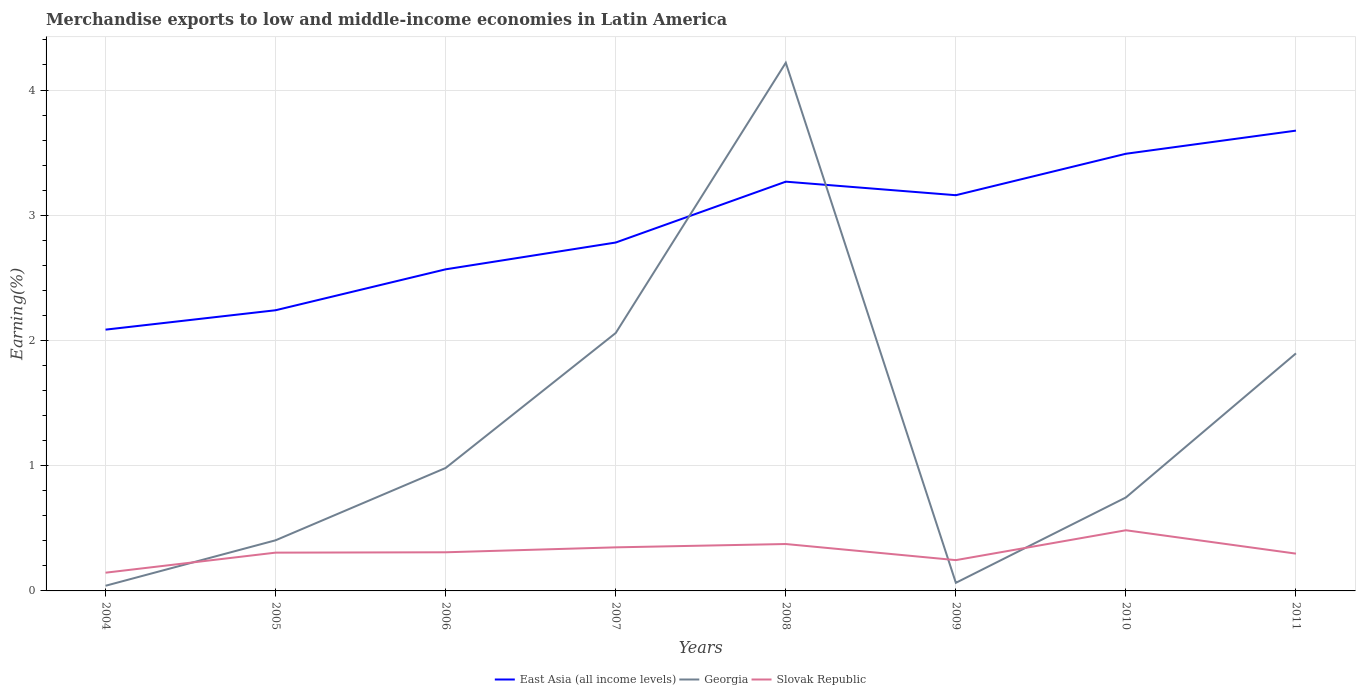Does the line corresponding to Georgia intersect with the line corresponding to East Asia (all income levels)?
Keep it short and to the point. Yes. Is the number of lines equal to the number of legend labels?
Your answer should be compact. Yes. Across all years, what is the maximum percentage of amount earned from merchandise exports in East Asia (all income levels)?
Your answer should be compact. 2.09. In which year was the percentage of amount earned from merchandise exports in Slovak Republic maximum?
Your answer should be compact. 2004. What is the total percentage of amount earned from merchandise exports in Georgia in the graph?
Provide a short and direct response. -1.08. What is the difference between the highest and the second highest percentage of amount earned from merchandise exports in East Asia (all income levels)?
Your response must be concise. 1.59. What is the difference between the highest and the lowest percentage of amount earned from merchandise exports in Georgia?
Provide a succinct answer. 3. How many years are there in the graph?
Your answer should be very brief. 8. What is the difference between two consecutive major ticks on the Y-axis?
Provide a short and direct response. 1. Are the values on the major ticks of Y-axis written in scientific E-notation?
Give a very brief answer. No. Does the graph contain grids?
Offer a terse response. Yes. What is the title of the graph?
Provide a succinct answer. Merchandise exports to low and middle-income economies in Latin America. Does "Fragile and conflict affected situations" appear as one of the legend labels in the graph?
Provide a short and direct response. No. What is the label or title of the X-axis?
Give a very brief answer. Years. What is the label or title of the Y-axis?
Provide a succinct answer. Earning(%). What is the Earning(%) in East Asia (all income levels) in 2004?
Offer a terse response. 2.09. What is the Earning(%) in Georgia in 2004?
Ensure brevity in your answer.  0.04. What is the Earning(%) of Slovak Republic in 2004?
Your response must be concise. 0.15. What is the Earning(%) in East Asia (all income levels) in 2005?
Ensure brevity in your answer.  2.24. What is the Earning(%) of Georgia in 2005?
Make the answer very short. 0.4. What is the Earning(%) of Slovak Republic in 2005?
Keep it short and to the point. 0.31. What is the Earning(%) of East Asia (all income levels) in 2006?
Provide a short and direct response. 2.57. What is the Earning(%) of Georgia in 2006?
Ensure brevity in your answer.  0.98. What is the Earning(%) in Slovak Republic in 2006?
Keep it short and to the point. 0.31. What is the Earning(%) in East Asia (all income levels) in 2007?
Give a very brief answer. 2.78. What is the Earning(%) in Georgia in 2007?
Give a very brief answer. 2.06. What is the Earning(%) of Slovak Republic in 2007?
Offer a very short reply. 0.35. What is the Earning(%) of East Asia (all income levels) in 2008?
Your answer should be very brief. 3.27. What is the Earning(%) in Georgia in 2008?
Give a very brief answer. 4.22. What is the Earning(%) of Slovak Republic in 2008?
Your response must be concise. 0.37. What is the Earning(%) of East Asia (all income levels) in 2009?
Ensure brevity in your answer.  3.16. What is the Earning(%) in Georgia in 2009?
Provide a succinct answer. 0.06. What is the Earning(%) of Slovak Republic in 2009?
Ensure brevity in your answer.  0.25. What is the Earning(%) of East Asia (all income levels) in 2010?
Offer a terse response. 3.49. What is the Earning(%) in Georgia in 2010?
Offer a very short reply. 0.75. What is the Earning(%) of Slovak Republic in 2010?
Ensure brevity in your answer.  0.48. What is the Earning(%) in East Asia (all income levels) in 2011?
Your answer should be compact. 3.68. What is the Earning(%) in Georgia in 2011?
Your answer should be compact. 1.9. What is the Earning(%) of Slovak Republic in 2011?
Provide a short and direct response. 0.3. Across all years, what is the maximum Earning(%) in East Asia (all income levels)?
Provide a succinct answer. 3.68. Across all years, what is the maximum Earning(%) of Georgia?
Your answer should be very brief. 4.22. Across all years, what is the maximum Earning(%) of Slovak Republic?
Give a very brief answer. 0.48. Across all years, what is the minimum Earning(%) of East Asia (all income levels)?
Offer a terse response. 2.09. Across all years, what is the minimum Earning(%) of Georgia?
Make the answer very short. 0.04. Across all years, what is the minimum Earning(%) in Slovak Republic?
Your answer should be very brief. 0.15. What is the total Earning(%) in East Asia (all income levels) in the graph?
Offer a terse response. 23.27. What is the total Earning(%) of Georgia in the graph?
Keep it short and to the point. 10.41. What is the total Earning(%) of Slovak Republic in the graph?
Your answer should be very brief. 2.51. What is the difference between the Earning(%) of East Asia (all income levels) in 2004 and that in 2005?
Offer a terse response. -0.15. What is the difference between the Earning(%) of Georgia in 2004 and that in 2005?
Provide a short and direct response. -0.36. What is the difference between the Earning(%) in Slovak Republic in 2004 and that in 2005?
Make the answer very short. -0.16. What is the difference between the Earning(%) of East Asia (all income levels) in 2004 and that in 2006?
Keep it short and to the point. -0.48. What is the difference between the Earning(%) in Georgia in 2004 and that in 2006?
Give a very brief answer. -0.94. What is the difference between the Earning(%) in Slovak Republic in 2004 and that in 2006?
Provide a succinct answer. -0.16. What is the difference between the Earning(%) of East Asia (all income levels) in 2004 and that in 2007?
Your response must be concise. -0.7. What is the difference between the Earning(%) of Georgia in 2004 and that in 2007?
Offer a very short reply. -2.02. What is the difference between the Earning(%) of Slovak Republic in 2004 and that in 2007?
Provide a short and direct response. -0.2. What is the difference between the Earning(%) of East Asia (all income levels) in 2004 and that in 2008?
Your response must be concise. -1.18. What is the difference between the Earning(%) in Georgia in 2004 and that in 2008?
Make the answer very short. -4.18. What is the difference between the Earning(%) in Slovak Republic in 2004 and that in 2008?
Your response must be concise. -0.23. What is the difference between the Earning(%) in East Asia (all income levels) in 2004 and that in 2009?
Your response must be concise. -1.07. What is the difference between the Earning(%) of Georgia in 2004 and that in 2009?
Provide a short and direct response. -0.02. What is the difference between the Earning(%) in Slovak Republic in 2004 and that in 2009?
Offer a terse response. -0.1. What is the difference between the Earning(%) of East Asia (all income levels) in 2004 and that in 2010?
Offer a terse response. -1.4. What is the difference between the Earning(%) in Georgia in 2004 and that in 2010?
Ensure brevity in your answer.  -0.71. What is the difference between the Earning(%) in Slovak Republic in 2004 and that in 2010?
Your answer should be very brief. -0.34. What is the difference between the Earning(%) in East Asia (all income levels) in 2004 and that in 2011?
Your answer should be very brief. -1.59. What is the difference between the Earning(%) in Georgia in 2004 and that in 2011?
Make the answer very short. -1.86. What is the difference between the Earning(%) in Slovak Republic in 2004 and that in 2011?
Provide a succinct answer. -0.15. What is the difference between the Earning(%) in East Asia (all income levels) in 2005 and that in 2006?
Ensure brevity in your answer.  -0.33. What is the difference between the Earning(%) of Georgia in 2005 and that in 2006?
Ensure brevity in your answer.  -0.58. What is the difference between the Earning(%) in Slovak Republic in 2005 and that in 2006?
Ensure brevity in your answer.  -0. What is the difference between the Earning(%) of East Asia (all income levels) in 2005 and that in 2007?
Provide a succinct answer. -0.54. What is the difference between the Earning(%) of Georgia in 2005 and that in 2007?
Provide a succinct answer. -1.66. What is the difference between the Earning(%) in Slovak Republic in 2005 and that in 2007?
Your answer should be very brief. -0.04. What is the difference between the Earning(%) in East Asia (all income levels) in 2005 and that in 2008?
Ensure brevity in your answer.  -1.03. What is the difference between the Earning(%) in Georgia in 2005 and that in 2008?
Ensure brevity in your answer.  -3.81. What is the difference between the Earning(%) in Slovak Republic in 2005 and that in 2008?
Ensure brevity in your answer.  -0.07. What is the difference between the Earning(%) of East Asia (all income levels) in 2005 and that in 2009?
Your answer should be very brief. -0.92. What is the difference between the Earning(%) of Georgia in 2005 and that in 2009?
Your response must be concise. 0.34. What is the difference between the Earning(%) in Slovak Republic in 2005 and that in 2009?
Your answer should be compact. 0.06. What is the difference between the Earning(%) in East Asia (all income levels) in 2005 and that in 2010?
Ensure brevity in your answer.  -1.25. What is the difference between the Earning(%) of Georgia in 2005 and that in 2010?
Offer a very short reply. -0.34. What is the difference between the Earning(%) of Slovak Republic in 2005 and that in 2010?
Your answer should be very brief. -0.18. What is the difference between the Earning(%) in East Asia (all income levels) in 2005 and that in 2011?
Keep it short and to the point. -1.43. What is the difference between the Earning(%) in Georgia in 2005 and that in 2011?
Your answer should be very brief. -1.49. What is the difference between the Earning(%) of Slovak Republic in 2005 and that in 2011?
Provide a short and direct response. 0.01. What is the difference between the Earning(%) of East Asia (all income levels) in 2006 and that in 2007?
Your answer should be compact. -0.21. What is the difference between the Earning(%) of Georgia in 2006 and that in 2007?
Offer a terse response. -1.08. What is the difference between the Earning(%) of Slovak Republic in 2006 and that in 2007?
Your response must be concise. -0.04. What is the difference between the Earning(%) in Georgia in 2006 and that in 2008?
Offer a very short reply. -3.24. What is the difference between the Earning(%) of Slovak Republic in 2006 and that in 2008?
Provide a short and direct response. -0.07. What is the difference between the Earning(%) in East Asia (all income levels) in 2006 and that in 2009?
Keep it short and to the point. -0.59. What is the difference between the Earning(%) in Georgia in 2006 and that in 2009?
Give a very brief answer. 0.92. What is the difference between the Earning(%) in Slovak Republic in 2006 and that in 2009?
Give a very brief answer. 0.06. What is the difference between the Earning(%) in East Asia (all income levels) in 2006 and that in 2010?
Your response must be concise. -0.92. What is the difference between the Earning(%) in Georgia in 2006 and that in 2010?
Ensure brevity in your answer.  0.24. What is the difference between the Earning(%) in Slovak Republic in 2006 and that in 2010?
Make the answer very short. -0.18. What is the difference between the Earning(%) in East Asia (all income levels) in 2006 and that in 2011?
Make the answer very short. -1.11. What is the difference between the Earning(%) of Georgia in 2006 and that in 2011?
Ensure brevity in your answer.  -0.92. What is the difference between the Earning(%) in Slovak Republic in 2006 and that in 2011?
Provide a short and direct response. 0.01. What is the difference between the Earning(%) of East Asia (all income levels) in 2007 and that in 2008?
Your response must be concise. -0.49. What is the difference between the Earning(%) of Georgia in 2007 and that in 2008?
Your answer should be very brief. -2.16. What is the difference between the Earning(%) in Slovak Republic in 2007 and that in 2008?
Keep it short and to the point. -0.03. What is the difference between the Earning(%) of East Asia (all income levels) in 2007 and that in 2009?
Provide a short and direct response. -0.38. What is the difference between the Earning(%) in Georgia in 2007 and that in 2009?
Provide a short and direct response. 2. What is the difference between the Earning(%) of Slovak Republic in 2007 and that in 2009?
Offer a very short reply. 0.1. What is the difference between the Earning(%) of East Asia (all income levels) in 2007 and that in 2010?
Provide a short and direct response. -0.71. What is the difference between the Earning(%) in Georgia in 2007 and that in 2010?
Offer a very short reply. 1.31. What is the difference between the Earning(%) in Slovak Republic in 2007 and that in 2010?
Your answer should be very brief. -0.14. What is the difference between the Earning(%) in East Asia (all income levels) in 2007 and that in 2011?
Provide a succinct answer. -0.89. What is the difference between the Earning(%) in Georgia in 2007 and that in 2011?
Your answer should be very brief. 0.16. What is the difference between the Earning(%) in Slovak Republic in 2007 and that in 2011?
Offer a terse response. 0.05. What is the difference between the Earning(%) of East Asia (all income levels) in 2008 and that in 2009?
Your response must be concise. 0.11. What is the difference between the Earning(%) in Georgia in 2008 and that in 2009?
Ensure brevity in your answer.  4.15. What is the difference between the Earning(%) of Slovak Republic in 2008 and that in 2009?
Keep it short and to the point. 0.13. What is the difference between the Earning(%) in East Asia (all income levels) in 2008 and that in 2010?
Your answer should be very brief. -0.22. What is the difference between the Earning(%) in Georgia in 2008 and that in 2010?
Provide a succinct answer. 3.47. What is the difference between the Earning(%) of Slovak Republic in 2008 and that in 2010?
Your answer should be very brief. -0.11. What is the difference between the Earning(%) of East Asia (all income levels) in 2008 and that in 2011?
Make the answer very short. -0.41. What is the difference between the Earning(%) of Georgia in 2008 and that in 2011?
Your answer should be very brief. 2.32. What is the difference between the Earning(%) of Slovak Republic in 2008 and that in 2011?
Provide a short and direct response. 0.08. What is the difference between the Earning(%) in East Asia (all income levels) in 2009 and that in 2010?
Offer a terse response. -0.33. What is the difference between the Earning(%) of Georgia in 2009 and that in 2010?
Give a very brief answer. -0.68. What is the difference between the Earning(%) of Slovak Republic in 2009 and that in 2010?
Your response must be concise. -0.24. What is the difference between the Earning(%) of East Asia (all income levels) in 2009 and that in 2011?
Offer a terse response. -0.52. What is the difference between the Earning(%) in Georgia in 2009 and that in 2011?
Offer a terse response. -1.83. What is the difference between the Earning(%) in Slovak Republic in 2009 and that in 2011?
Give a very brief answer. -0.05. What is the difference between the Earning(%) in East Asia (all income levels) in 2010 and that in 2011?
Provide a succinct answer. -0.18. What is the difference between the Earning(%) in Georgia in 2010 and that in 2011?
Provide a succinct answer. -1.15. What is the difference between the Earning(%) in Slovak Republic in 2010 and that in 2011?
Your answer should be compact. 0.19. What is the difference between the Earning(%) of East Asia (all income levels) in 2004 and the Earning(%) of Georgia in 2005?
Give a very brief answer. 1.68. What is the difference between the Earning(%) in East Asia (all income levels) in 2004 and the Earning(%) in Slovak Republic in 2005?
Give a very brief answer. 1.78. What is the difference between the Earning(%) in Georgia in 2004 and the Earning(%) in Slovak Republic in 2005?
Your answer should be compact. -0.26. What is the difference between the Earning(%) of East Asia (all income levels) in 2004 and the Earning(%) of Georgia in 2006?
Offer a terse response. 1.1. What is the difference between the Earning(%) of East Asia (all income levels) in 2004 and the Earning(%) of Slovak Republic in 2006?
Ensure brevity in your answer.  1.78. What is the difference between the Earning(%) of Georgia in 2004 and the Earning(%) of Slovak Republic in 2006?
Keep it short and to the point. -0.27. What is the difference between the Earning(%) of East Asia (all income levels) in 2004 and the Earning(%) of Georgia in 2007?
Provide a succinct answer. 0.03. What is the difference between the Earning(%) of East Asia (all income levels) in 2004 and the Earning(%) of Slovak Republic in 2007?
Provide a short and direct response. 1.74. What is the difference between the Earning(%) in Georgia in 2004 and the Earning(%) in Slovak Republic in 2007?
Give a very brief answer. -0.31. What is the difference between the Earning(%) in East Asia (all income levels) in 2004 and the Earning(%) in Georgia in 2008?
Your answer should be very brief. -2.13. What is the difference between the Earning(%) in East Asia (all income levels) in 2004 and the Earning(%) in Slovak Republic in 2008?
Provide a succinct answer. 1.71. What is the difference between the Earning(%) in Georgia in 2004 and the Earning(%) in Slovak Republic in 2008?
Give a very brief answer. -0.33. What is the difference between the Earning(%) in East Asia (all income levels) in 2004 and the Earning(%) in Georgia in 2009?
Provide a succinct answer. 2.02. What is the difference between the Earning(%) in East Asia (all income levels) in 2004 and the Earning(%) in Slovak Republic in 2009?
Offer a terse response. 1.84. What is the difference between the Earning(%) in Georgia in 2004 and the Earning(%) in Slovak Republic in 2009?
Your answer should be compact. -0.2. What is the difference between the Earning(%) of East Asia (all income levels) in 2004 and the Earning(%) of Georgia in 2010?
Offer a terse response. 1.34. What is the difference between the Earning(%) in East Asia (all income levels) in 2004 and the Earning(%) in Slovak Republic in 2010?
Your response must be concise. 1.6. What is the difference between the Earning(%) in Georgia in 2004 and the Earning(%) in Slovak Republic in 2010?
Your response must be concise. -0.44. What is the difference between the Earning(%) of East Asia (all income levels) in 2004 and the Earning(%) of Georgia in 2011?
Your answer should be compact. 0.19. What is the difference between the Earning(%) of East Asia (all income levels) in 2004 and the Earning(%) of Slovak Republic in 2011?
Offer a terse response. 1.79. What is the difference between the Earning(%) in Georgia in 2004 and the Earning(%) in Slovak Republic in 2011?
Your response must be concise. -0.26. What is the difference between the Earning(%) in East Asia (all income levels) in 2005 and the Earning(%) in Georgia in 2006?
Offer a terse response. 1.26. What is the difference between the Earning(%) in East Asia (all income levels) in 2005 and the Earning(%) in Slovak Republic in 2006?
Make the answer very short. 1.93. What is the difference between the Earning(%) in Georgia in 2005 and the Earning(%) in Slovak Republic in 2006?
Your response must be concise. 0.1. What is the difference between the Earning(%) in East Asia (all income levels) in 2005 and the Earning(%) in Georgia in 2007?
Ensure brevity in your answer.  0.18. What is the difference between the Earning(%) of East Asia (all income levels) in 2005 and the Earning(%) of Slovak Republic in 2007?
Provide a short and direct response. 1.89. What is the difference between the Earning(%) of Georgia in 2005 and the Earning(%) of Slovak Republic in 2007?
Provide a succinct answer. 0.06. What is the difference between the Earning(%) in East Asia (all income levels) in 2005 and the Earning(%) in Georgia in 2008?
Your answer should be compact. -1.98. What is the difference between the Earning(%) in East Asia (all income levels) in 2005 and the Earning(%) in Slovak Republic in 2008?
Your answer should be compact. 1.87. What is the difference between the Earning(%) of Georgia in 2005 and the Earning(%) of Slovak Republic in 2008?
Your answer should be very brief. 0.03. What is the difference between the Earning(%) in East Asia (all income levels) in 2005 and the Earning(%) in Georgia in 2009?
Your response must be concise. 2.18. What is the difference between the Earning(%) of East Asia (all income levels) in 2005 and the Earning(%) of Slovak Republic in 2009?
Provide a short and direct response. 2. What is the difference between the Earning(%) in Georgia in 2005 and the Earning(%) in Slovak Republic in 2009?
Your answer should be very brief. 0.16. What is the difference between the Earning(%) of East Asia (all income levels) in 2005 and the Earning(%) of Georgia in 2010?
Offer a terse response. 1.5. What is the difference between the Earning(%) of East Asia (all income levels) in 2005 and the Earning(%) of Slovak Republic in 2010?
Offer a terse response. 1.76. What is the difference between the Earning(%) of Georgia in 2005 and the Earning(%) of Slovak Republic in 2010?
Your response must be concise. -0.08. What is the difference between the Earning(%) of East Asia (all income levels) in 2005 and the Earning(%) of Georgia in 2011?
Provide a succinct answer. 0.34. What is the difference between the Earning(%) in East Asia (all income levels) in 2005 and the Earning(%) in Slovak Republic in 2011?
Your answer should be very brief. 1.94. What is the difference between the Earning(%) of Georgia in 2005 and the Earning(%) of Slovak Republic in 2011?
Give a very brief answer. 0.11. What is the difference between the Earning(%) in East Asia (all income levels) in 2006 and the Earning(%) in Georgia in 2007?
Your answer should be very brief. 0.51. What is the difference between the Earning(%) in East Asia (all income levels) in 2006 and the Earning(%) in Slovak Republic in 2007?
Provide a succinct answer. 2.22. What is the difference between the Earning(%) in Georgia in 2006 and the Earning(%) in Slovak Republic in 2007?
Keep it short and to the point. 0.63. What is the difference between the Earning(%) in East Asia (all income levels) in 2006 and the Earning(%) in Georgia in 2008?
Offer a very short reply. -1.65. What is the difference between the Earning(%) in East Asia (all income levels) in 2006 and the Earning(%) in Slovak Republic in 2008?
Your answer should be compact. 2.19. What is the difference between the Earning(%) of Georgia in 2006 and the Earning(%) of Slovak Republic in 2008?
Your answer should be very brief. 0.61. What is the difference between the Earning(%) of East Asia (all income levels) in 2006 and the Earning(%) of Georgia in 2009?
Keep it short and to the point. 2.5. What is the difference between the Earning(%) in East Asia (all income levels) in 2006 and the Earning(%) in Slovak Republic in 2009?
Offer a very short reply. 2.32. What is the difference between the Earning(%) of Georgia in 2006 and the Earning(%) of Slovak Republic in 2009?
Ensure brevity in your answer.  0.74. What is the difference between the Earning(%) in East Asia (all income levels) in 2006 and the Earning(%) in Georgia in 2010?
Your answer should be very brief. 1.82. What is the difference between the Earning(%) in East Asia (all income levels) in 2006 and the Earning(%) in Slovak Republic in 2010?
Your response must be concise. 2.08. What is the difference between the Earning(%) in Georgia in 2006 and the Earning(%) in Slovak Republic in 2010?
Your response must be concise. 0.5. What is the difference between the Earning(%) in East Asia (all income levels) in 2006 and the Earning(%) in Georgia in 2011?
Give a very brief answer. 0.67. What is the difference between the Earning(%) in East Asia (all income levels) in 2006 and the Earning(%) in Slovak Republic in 2011?
Provide a short and direct response. 2.27. What is the difference between the Earning(%) in Georgia in 2006 and the Earning(%) in Slovak Republic in 2011?
Provide a succinct answer. 0.68. What is the difference between the Earning(%) of East Asia (all income levels) in 2007 and the Earning(%) of Georgia in 2008?
Your response must be concise. -1.44. What is the difference between the Earning(%) of East Asia (all income levels) in 2007 and the Earning(%) of Slovak Republic in 2008?
Your answer should be compact. 2.41. What is the difference between the Earning(%) of Georgia in 2007 and the Earning(%) of Slovak Republic in 2008?
Your response must be concise. 1.69. What is the difference between the Earning(%) in East Asia (all income levels) in 2007 and the Earning(%) in Georgia in 2009?
Your response must be concise. 2.72. What is the difference between the Earning(%) in East Asia (all income levels) in 2007 and the Earning(%) in Slovak Republic in 2009?
Make the answer very short. 2.54. What is the difference between the Earning(%) of Georgia in 2007 and the Earning(%) of Slovak Republic in 2009?
Ensure brevity in your answer.  1.81. What is the difference between the Earning(%) of East Asia (all income levels) in 2007 and the Earning(%) of Georgia in 2010?
Keep it short and to the point. 2.04. What is the difference between the Earning(%) of East Asia (all income levels) in 2007 and the Earning(%) of Slovak Republic in 2010?
Provide a succinct answer. 2.3. What is the difference between the Earning(%) of Georgia in 2007 and the Earning(%) of Slovak Republic in 2010?
Provide a short and direct response. 1.58. What is the difference between the Earning(%) of East Asia (all income levels) in 2007 and the Earning(%) of Georgia in 2011?
Keep it short and to the point. 0.89. What is the difference between the Earning(%) of East Asia (all income levels) in 2007 and the Earning(%) of Slovak Republic in 2011?
Your response must be concise. 2.48. What is the difference between the Earning(%) of Georgia in 2007 and the Earning(%) of Slovak Republic in 2011?
Provide a short and direct response. 1.76. What is the difference between the Earning(%) of East Asia (all income levels) in 2008 and the Earning(%) of Georgia in 2009?
Give a very brief answer. 3.2. What is the difference between the Earning(%) of East Asia (all income levels) in 2008 and the Earning(%) of Slovak Republic in 2009?
Your answer should be compact. 3.02. What is the difference between the Earning(%) of Georgia in 2008 and the Earning(%) of Slovak Republic in 2009?
Provide a succinct answer. 3.97. What is the difference between the Earning(%) of East Asia (all income levels) in 2008 and the Earning(%) of Georgia in 2010?
Your response must be concise. 2.52. What is the difference between the Earning(%) in East Asia (all income levels) in 2008 and the Earning(%) in Slovak Republic in 2010?
Provide a short and direct response. 2.78. What is the difference between the Earning(%) of Georgia in 2008 and the Earning(%) of Slovak Republic in 2010?
Keep it short and to the point. 3.73. What is the difference between the Earning(%) of East Asia (all income levels) in 2008 and the Earning(%) of Georgia in 2011?
Provide a short and direct response. 1.37. What is the difference between the Earning(%) in East Asia (all income levels) in 2008 and the Earning(%) in Slovak Republic in 2011?
Give a very brief answer. 2.97. What is the difference between the Earning(%) of Georgia in 2008 and the Earning(%) of Slovak Republic in 2011?
Ensure brevity in your answer.  3.92. What is the difference between the Earning(%) of East Asia (all income levels) in 2009 and the Earning(%) of Georgia in 2010?
Your answer should be very brief. 2.41. What is the difference between the Earning(%) of East Asia (all income levels) in 2009 and the Earning(%) of Slovak Republic in 2010?
Provide a succinct answer. 2.68. What is the difference between the Earning(%) of Georgia in 2009 and the Earning(%) of Slovak Republic in 2010?
Offer a very short reply. -0.42. What is the difference between the Earning(%) in East Asia (all income levels) in 2009 and the Earning(%) in Georgia in 2011?
Your answer should be very brief. 1.26. What is the difference between the Earning(%) of East Asia (all income levels) in 2009 and the Earning(%) of Slovak Republic in 2011?
Your answer should be very brief. 2.86. What is the difference between the Earning(%) in Georgia in 2009 and the Earning(%) in Slovak Republic in 2011?
Provide a succinct answer. -0.23. What is the difference between the Earning(%) in East Asia (all income levels) in 2010 and the Earning(%) in Georgia in 2011?
Your answer should be very brief. 1.59. What is the difference between the Earning(%) of East Asia (all income levels) in 2010 and the Earning(%) of Slovak Republic in 2011?
Ensure brevity in your answer.  3.19. What is the difference between the Earning(%) in Georgia in 2010 and the Earning(%) in Slovak Republic in 2011?
Offer a very short reply. 0.45. What is the average Earning(%) of East Asia (all income levels) per year?
Give a very brief answer. 2.91. What is the average Earning(%) in Georgia per year?
Your answer should be very brief. 1.3. What is the average Earning(%) of Slovak Republic per year?
Provide a succinct answer. 0.31. In the year 2004, what is the difference between the Earning(%) of East Asia (all income levels) and Earning(%) of Georgia?
Your response must be concise. 2.05. In the year 2004, what is the difference between the Earning(%) of East Asia (all income levels) and Earning(%) of Slovak Republic?
Provide a succinct answer. 1.94. In the year 2004, what is the difference between the Earning(%) of Georgia and Earning(%) of Slovak Republic?
Provide a short and direct response. -0.1. In the year 2005, what is the difference between the Earning(%) in East Asia (all income levels) and Earning(%) in Georgia?
Provide a short and direct response. 1.84. In the year 2005, what is the difference between the Earning(%) in East Asia (all income levels) and Earning(%) in Slovak Republic?
Your answer should be very brief. 1.94. In the year 2005, what is the difference between the Earning(%) of Georgia and Earning(%) of Slovak Republic?
Offer a terse response. 0.1. In the year 2006, what is the difference between the Earning(%) in East Asia (all income levels) and Earning(%) in Georgia?
Your response must be concise. 1.59. In the year 2006, what is the difference between the Earning(%) of East Asia (all income levels) and Earning(%) of Slovak Republic?
Your answer should be very brief. 2.26. In the year 2006, what is the difference between the Earning(%) of Georgia and Earning(%) of Slovak Republic?
Ensure brevity in your answer.  0.67. In the year 2007, what is the difference between the Earning(%) of East Asia (all income levels) and Earning(%) of Georgia?
Your answer should be very brief. 0.72. In the year 2007, what is the difference between the Earning(%) of East Asia (all income levels) and Earning(%) of Slovak Republic?
Provide a succinct answer. 2.43. In the year 2007, what is the difference between the Earning(%) in Georgia and Earning(%) in Slovak Republic?
Offer a terse response. 1.71. In the year 2008, what is the difference between the Earning(%) in East Asia (all income levels) and Earning(%) in Georgia?
Offer a terse response. -0.95. In the year 2008, what is the difference between the Earning(%) of East Asia (all income levels) and Earning(%) of Slovak Republic?
Make the answer very short. 2.89. In the year 2008, what is the difference between the Earning(%) in Georgia and Earning(%) in Slovak Republic?
Provide a succinct answer. 3.84. In the year 2009, what is the difference between the Earning(%) in East Asia (all income levels) and Earning(%) in Georgia?
Provide a succinct answer. 3.1. In the year 2009, what is the difference between the Earning(%) in East Asia (all income levels) and Earning(%) in Slovak Republic?
Offer a terse response. 2.91. In the year 2009, what is the difference between the Earning(%) in Georgia and Earning(%) in Slovak Republic?
Your answer should be very brief. -0.18. In the year 2010, what is the difference between the Earning(%) in East Asia (all income levels) and Earning(%) in Georgia?
Offer a very short reply. 2.74. In the year 2010, what is the difference between the Earning(%) in East Asia (all income levels) and Earning(%) in Slovak Republic?
Give a very brief answer. 3.01. In the year 2010, what is the difference between the Earning(%) of Georgia and Earning(%) of Slovak Republic?
Ensure brevity in your answer.  0.26. In the year 2011, what is the difference between the Earning(%) of East Asia (all income levels) and Earning(%) of Georgia?
Offer a terse response. 1.78. In the year 2011, what is the difference between the Earning(%) of East Asia (all income levels) and Earning(%) of Slovak Republic?
Offer a terse response. 3.38. In the year 2011, what is the difference between the Earning(%) of Georgia and Earning(%) of Slovak Republic?
Provide a short and direct response. 1.6. What is the ratio of the Earning(%) in East Asia (all income levels) in 2004 to that in 2005?
Make the answer very short. 0.93. What is the ratio of the Earning(%) in Georgia in 2004 to that in 2005?
Keep it short and to the point. 0.1. What is the ratio of the Earning(%) of Slovak Republic in 2004 to that in 2005?
Give a very brief answer. 0.48. What is the ratio of the Earning(%) in East Asia (all income levels) in 2004 to that in 2006?
Keep it short and to the point. 0.81. What is the ratio of the Earning(%) in Georgia in 2004 to that in 2006?
Keep it short and to the point. 0.04. What is the ratio of the Earning(%) of Slovak Republic in 2004 to that in 2006?
Your response must be concise. 0.47. What is the ratio of the Earning(%) in Slovak Republic in 2004 to that in 2007?
Your response must be concise. 0.42. What is the ratio of the Earning(%) of East Asia (all income levels) in 2004 to that in 2008?
Make the answer very short. 0.64. What is the ratio of the Earning(%) in Georgia in 2004 to that in 2008?
Make the answer very short. 0.01. What is the ratio of the Earning(%) in Slovak Republic in 2004 to that in 2008?
Provide a short and direct response. 0.39. What is the ratio of the Earning(%) in East Asia (all income levels) in 2004 to that in 2009?
Provide a succinct answer. 0.66. What is the ratio of the Earning(%) of Georgia in 2004 to that in 2009?
Provide a short and direct response. 0.64. What is the ratio of the Earning(%) of Slovak Republic in 2004 to that in 2009?
Keep it short and to the point. 0.59. What is the ratio of the Earning(%) in East Asia (all income levels) in 2004 to that in 2010?
Your response must be concise. 0.6. What is the ratio of the Earning(%) of Georgia in 2004 to that in 2010?
Provide a succinct answer. 0.06. What is the ratio of the Earning(%) of Slovak Republic in 2004 to that in 2010?
Keep it short and to the point. 0.3. What is the ratio of the Earning(%) in East Asia (all income levels) in 2004 to that in 2011?
Offer a terse response. 0.57. What is the ratio of the Earning(%) in Georgia in 2004 to that in 2011?
Keep it short and to the point. 0.02. What is the ratio of the Earning(%) of Slovak Republic in 2004 to that in 2011?
Your answer should be very brief. 0.49. What is the ratio of the Earning(%) of East Asia (all income levels) in 2005 to that in 2006?
Give a very brief answer. 0.87. What is the ratio of the Earning(%) of Georgia in 2005 to that in 2006?
Offer a very short reply. 0.41. What is the ratio of the Earning(%) in Slovak Republic in 2005 to that in 2006?
Give a very brief answer. 0.99. What is the ratio of the Earning(%) in East Asia (all income levels) in 2005 to that in 2007?
Make the answer very short. 0.81. What is the ratio of the Earning(%) in Georgia in 2005 to that in 2007?
Keep it short and to the point. 0.2. What is the ratio of the Earning(%) in Slovak Republic in 2005 to that in 2007?
Offer a terse response. 0.88. What is the ratio of the Earning(%) of East Asia (all income levels) in 2005 to that in 2008?
Make the answer very short. 0.69. What is the ratio of the Earning(%) in Georgia in 2005 to that in 2008?
Offer a very short reply. 0.1. What is the ratio of the Earning(%) in Slovak Republic in 2005 to that in 2008?
Give a very brief answer. 0.82. What is the ratio of the Earning(%) of East Asia (all income levels) in 2005 to that in 2009?
Provide a succinct answer. 0.71. What is the ratio of the Earning(%) of Georgia in 2005 to that in 2009?
Keep it short and to the point. 6.25. What is the ratio of the Earning(%) in Slovak Republic in 2005 to that in 2009?
Your answer should be compact. 1.24. What is the ratio of the Earning(%) in East Asia (all income levels) in 2005 to that in 2010?
Your response must be concise. 0.64. What is the ratio of the Earning(%) in Georgia in 2005 to that in 2010?
Your answer should be compact. 0.54. What is the ratio of the Earning(%) in Slovak Republic in 2005 to that in 2010?
Provide a succinct answer. 0.63. What is the ratio of the Earning(%) in East Asia (all income levels) in 2005 to that in 2011?
Your answer should be compact. 0.61. What is the ratio of the Earning(%) of Georgia in 2005 to that in 2011?
Make the answer very short. 0.21. What is the ratio of the Earning(%) in Slovak Republic in 2005 to that in 2011?
Your response must be concise. 1.03. What is the ratio of the Earning(%) in Georgia in 2006 to that in 2007?
Offer a very short reply. 0.48. What is the ratio of the Earning(%) of Slovak Republic in 2006 to that in 2007?
Ensure brevity in your answer.  0.89. What is the ratio of the Earning(%) of East Asia (all income levels) in 2006 to that in 2008?
Your answer should be very brief. 0.79. What is the ratio of the Earning(%) of Georgia in 2006 to that in 2008?
Provide a short and direct response. 0.23. What is the ratio of the Earning(%) in Slovak Republic in 2006 to that in 2008?
Provide a short and direct response. 0.82. What is the ratio of the Earning(%) in East Asia (all income levels) in 2006 to that in 2009?
Ensure brevity in your answer.  0.81. What is the ratio of the Earning(%) of Georgia in 2006 to that in 2009?
Offer a terse response. 15.18. What is the ratio of the Earning(%) in Slovak Republic in 2006 to that in 2009?
Your answer should be compact. 1.25. What is the ratio of the Earning(%) of East Asia (all income levels) in 2006 to that in 2010?
Keep it short and to the point. 0.74. What is the ratio of the Earning(%) in Georgia in 2006 to that in 2010?
Your response must be concise. 1.32. What is the ratio of the Earning(%) in Slovak Republic in 2006 to that in 2010?
Ensure brevity in your answer.  0.64. What is the ratio of the Earning(%) in East Asia (all income levels) in 2006 to that in 2011?
Make the answer very short. 0.7. What is the ratio of the Earning(%) in Georgia in 2006 to that in 2011?
Give a very brief answer. 0.52. What is the ratio of the Earning(%) of Slovak Republic in 2006 to that in 2011?
Your answer should be very brief. 1.04. What is the ratio of the Earning(%) of East Asia (all income levels) in 2007 to that in 2008?
Provide a succinct answer. 0.85. What is the ratio of the Earning(%) of Georgia in 2007 to that in 2008?
Make the answer very short. 0.49. What is the ratio of the Earning(%) in Slovak Republic in 2007 to that in 2008?
Offer a terse response. 0.93. What is the ratio of the Earning(%) of East Asia (all income levels) in 2007 to that in 2009?
Make the answer very short. 0.88. What is the ratio of the Earning(%) in Georgia in 2007 to that in 2009?
Offer a very short reply. 31.84. What is the ratio of the Earning(%) of Slovak Republic in 2007 to that in 2009?
Your response must be concise. 1.42. What is the ratio of the Earning(%) of East Asia (all income levels) in 2007 to that in 2010?
Provide a succinct answer. 0.8. What is the ratio of the Earning(%) of Georgia in 2007 to that in 2010?
Your answer should be very brief. 2.76. What is the ratio of the Earning(%) in Slovak Republic in 2007 to that in 2010?
Keep it short and to the point. 0.72. What is the ratio of the Earning(%) of East Asia (all income levels) in 2007 to that in 2011?
Give a very brief answer. 0.76. What is the ratio of the Earning(%) in Georgia in 2007 to that in 2011?
Your response must be concise. 1.09. What is the ratio of the Earning(%) in Slovak Republic in 2007 to that in 2011?
Your answer should be compact. 1.17. What is the ratio of the Earning(%) of East Asia (all income levels) in 2008 to that in 2009?
Ensure brevity in your answer.  1.03. What is the ratio of the Earning(%) of Georgia in 2008 to that in 2009?
Provide a succinct answer. 65.21. What is the ratio of the Earning(%) in Slovak Republic in 2008 to that in 2009?
Ensure brevity in your answer.  1.52. What is the ratio of the Earning(%) of East Asia (all income levels) in 2008 to that in 2010?
Provide a short and direct response. 0.94. What is the ratio of the Earning(%) in Georgia in 2008 to that in 2010?
Provide a short and direct response. 5.65. What is the ratio of the Earning(%) in Slovak Republic in 2008 to that in 2010?
Make the answer very short. 0.77. What is the ratio of the Earning(%) of East Asia (all income levels) in 2008 to that in 2011?
Your answer should be very brief. 0.89. What is the ratio of the Earning(%) of Georgia in 2008 to that in 2011?
Give a very brief answer. 2.22. What is the ratio of the Earning(%) in Slovak Republic in 2008 to that in 2011?
Provide a succinct answer. 1.26. What is the ratio of the Earning(%) in East Asia (all income levels) in 2009 to that in 2010?
Keep it short and to the point. 0.91. What is the ratio of the Earning(%) of Georgia in 2009 to that in 2010?
Make the answer very short. 0.09. What is the ratio of the Earning(%) of Slovak Republic in 2009 to that in 2010?
Your answer should be compact. 0.51. What is the ratio of the Earning(%) of East Asia (all income levels) in 2009 to that in 2011?
Your response must be concise. 0.86. What is the ratio of the Earning(%) of Georgia in 2009 to that in 2011?
Give a very brief answer. 0.03. What is the ratio of the Earning(%) in Slovak Republic in 2009 to that in 2011?
Make the answer very short. 0.83. What is the ratio of the Earning(%) in East Asia (all income levels) in 2010 to that in 2011?
Offer a terse response. 0.95. What is the ratio of the Earning(%) in Georgia in 2010 to that in 2011?
Offer a very short reply. 0.39. What is the ratio of the Earning(%) of Slovak Republic in 2010 to that in 2011?
Offer a very short reply. 1.63. What is the difference between the highest and the second highest Earning(%) of East Asia (all income levels)?
Give a very brief answer. 0.18. What is the difference between the highest and the second highest Earning(%) in Georgia?
Give a very brief answer. 2.16. What is the difference between the highest and the second highest Earning(%) of Slovak Republic?
Give a very brief answer. 0.11. What is the difference between the highest and the lowest Earning(%) of East Asia (all income levels)?
Provide a short and direct response. 1.59. What is the difference between the highest and the lowest Earning(%) of Georgia?
Ensure brevity in your answer.  4.18. What is the difference between the highest and the lowest Earning(%) in Slovak Republic?
Provide a succinct answer. 0.34. 